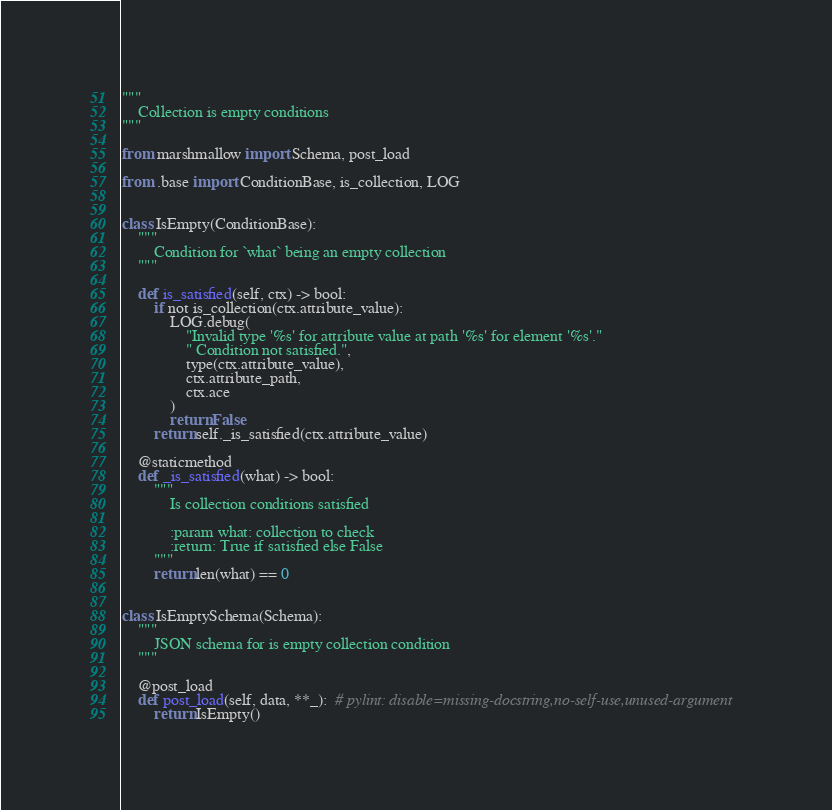<code> <loc_0><loc_0><loc_500><loc_500><_Python_>"""
    Collection is empty conditions
"""

from marshmallow import Schema, post_load

from .base import ConditionBase, is_collection, LOG


class IsEmpty(ConditionBase):
    """
        Condition for `what` being an empty collection
    """

    def is_satisfied(self, ctx) -> bool:
        if not is_collection(ctx.attribute_value):
            LOG.debug(
                "Invalid type '%s' for attribute value at path '%s' for element '%s'."
                " Condition not satisfied.",
                type(ctx.attribute_value),
                ctx.attribute_path,
                ctx.ace
            )
            return False
        return self._is_satisfied(ctx.attribute_value)

    @staticmethod
    def _is_satisfied(what) -> bool:
        """
            Is collection conditions satisfied

            :param what: collection to check
            :return: True if satisfied else False
        """
        return len(what) == 0


class IsEmptySchema(Schema):
    """
        JSON schema for is empty collection condition
    """

    @post_load
    def post_load(self, data, **_):  # pylint: disable=missing-docstring,no-self-use,unused-argument
        return IsEmpty()
</code> 